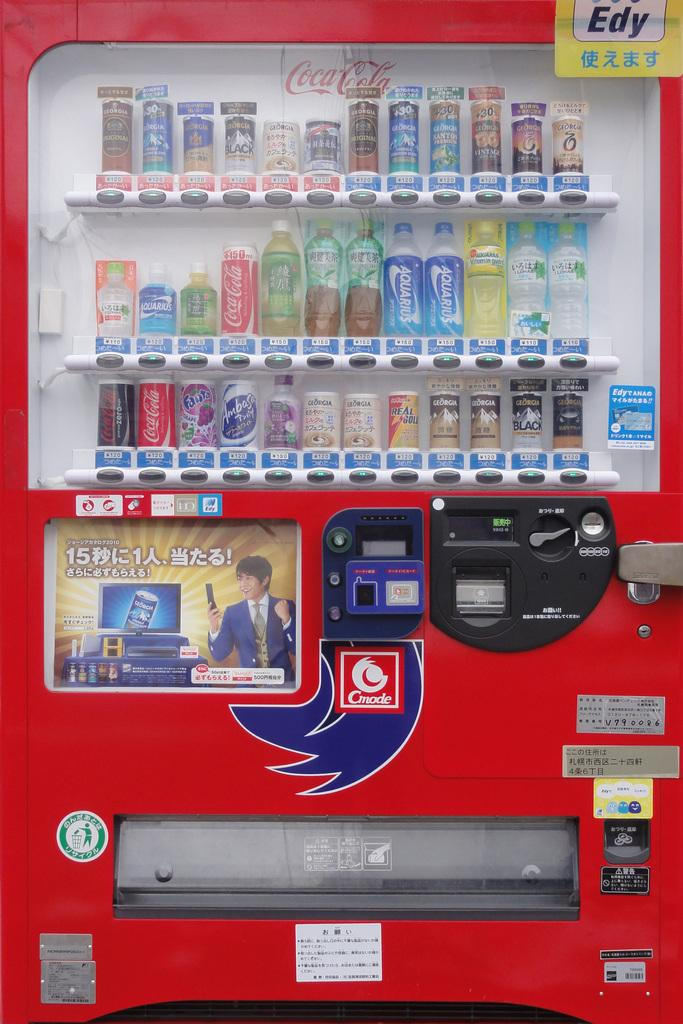<image>
Share a concise interpretation of the image provided. Vending machine for soft drinks with a square red sticker Cmode 